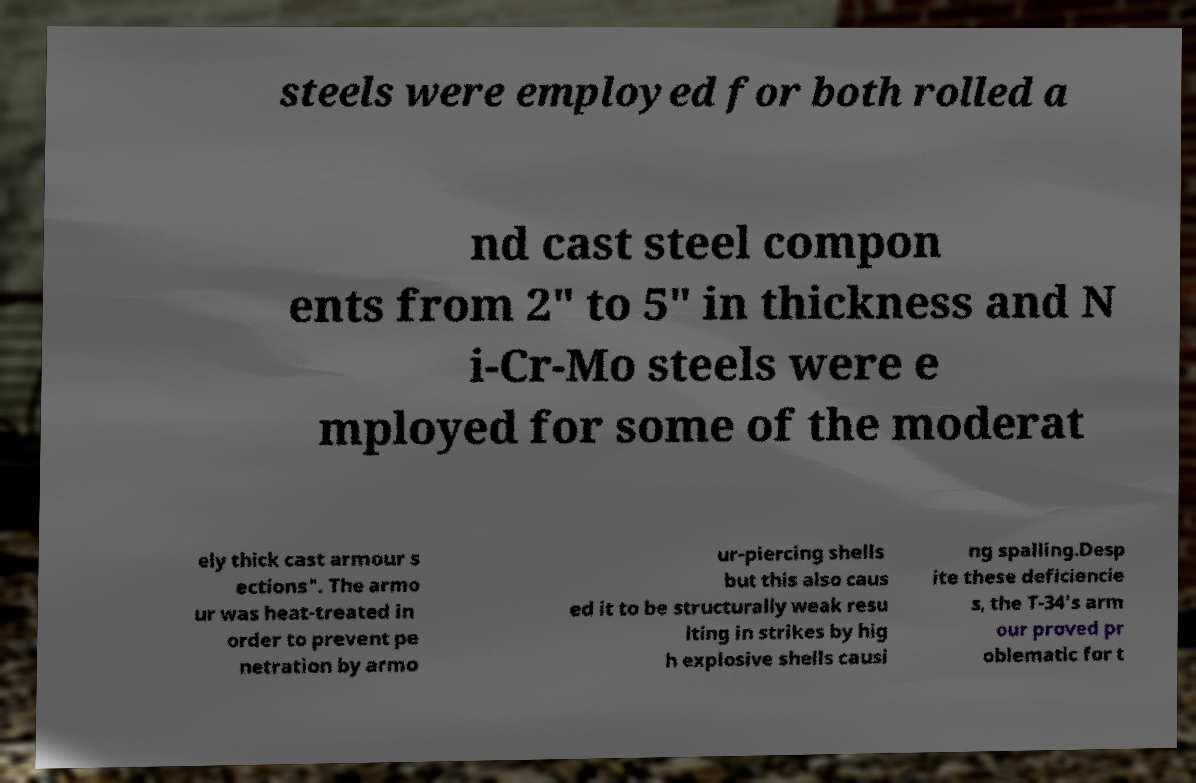Can you accurately transcribe the text from the provided image for me? steels were employed for both rolled a nd cast steel compon ents from 2" to 5" in thickness and N i-Cr-Mo steels were e mployed for some of the moderat ely thick cast armour s ections". The armo ur was heat-treated in order to prevent pe netration by armo ur-piercing shells but this also caus ed it to be structurally weak resu lting in strikes by hig h explosive shells causi ng spalling.Desp ite these deficiencie s, the T-34's arm our proved pr oblematic for t 